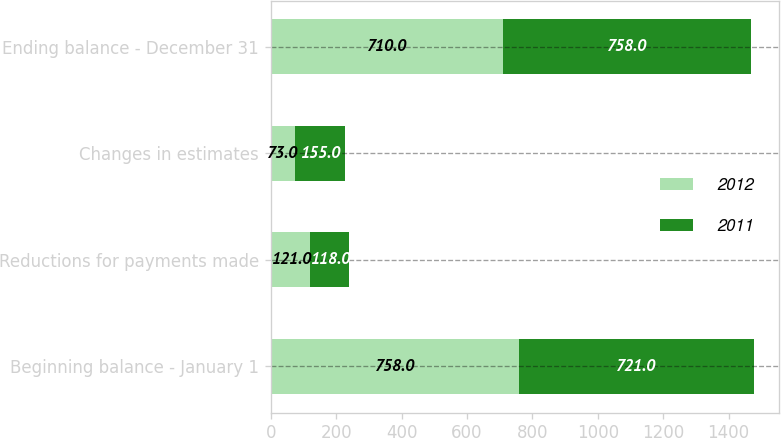Convert chart. <chart><loc_0><loc_0><loc_500><loc_500><stacked_bar_chart><ecel><fcel>Beginning balance - January 1<fcel>Reductions for payments made<fcel>Changes in estimates<fcel>Ending balance - December 31<nl><fcel>2012<fcel>758<fcel>121<fcel>73<fcel>710<nl><fcel>2011<fcel>721<fcel>118<fcel>155<fcel>758<nl></chart> 